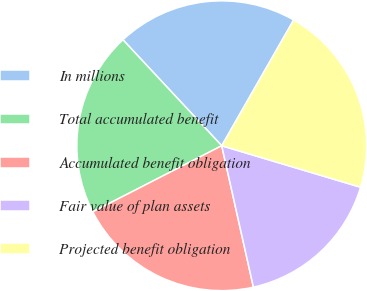Convert chart to OTSL. <chart><loc_0><loc_0><loc_500><loc_500><pie_chart><fcel>In millions<fcel>Total accumulated benefit<fcel>Accumulated benefit obligation<fcel>Fair value of plan assets<fcel>Projected benefit obligation<nl><fcel>20.21%<fcel>20.59%<fcel>20.97%<fcel>16.87%<fcel>21.35%<nl></chart> 